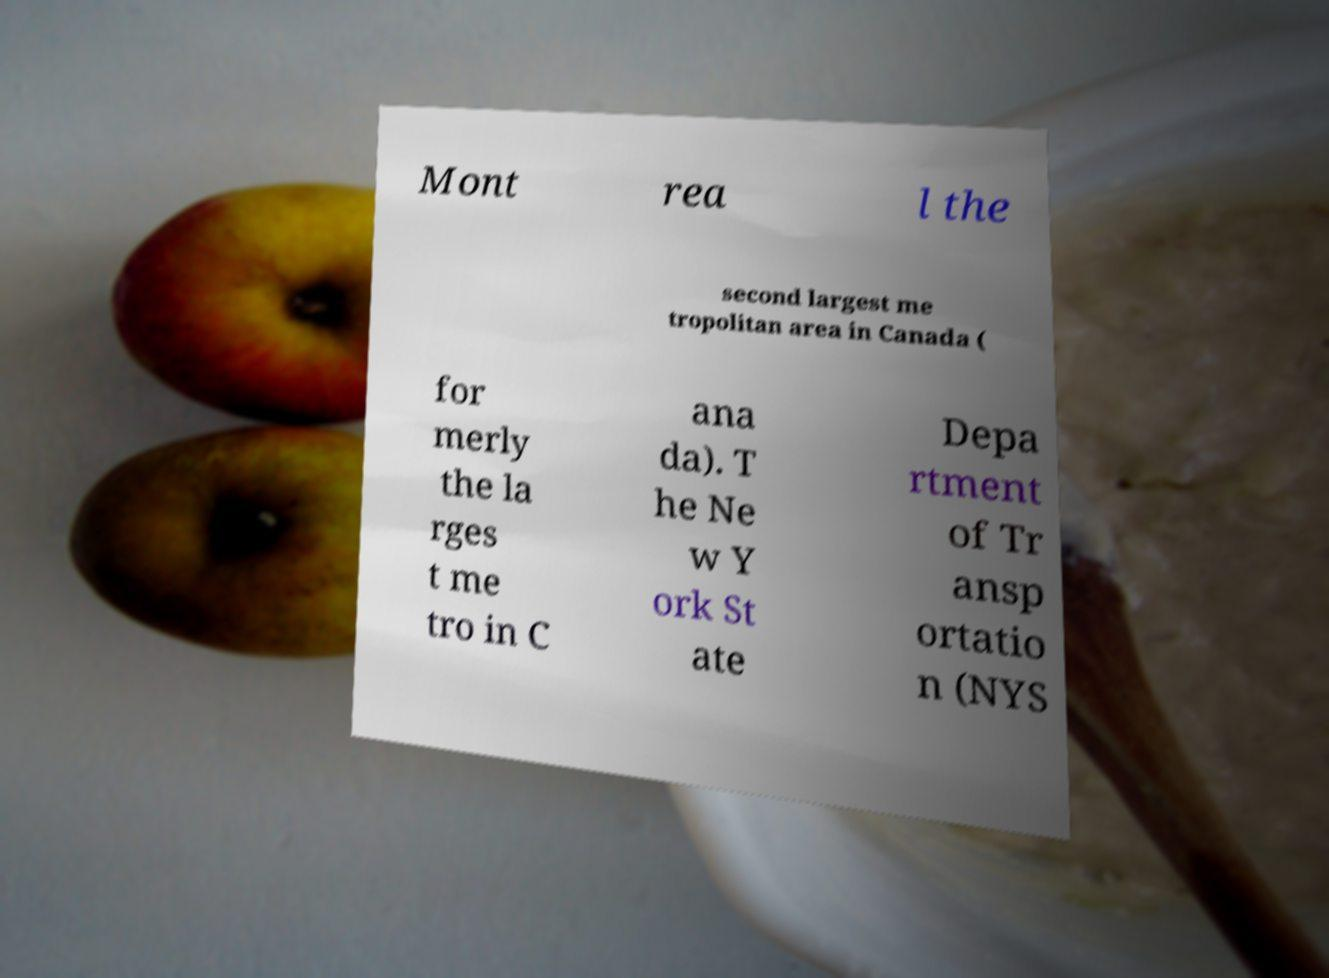There's text embedded in this image that I need extracted. Can you transcribe it verbatim? Mont rea l the second largest me tropolitan area in Canada ( for merly the la rges t me tro in C ana da). T he Ne w Y ork St ate Depa rtment of Tr ansp ortatio n (NYS 